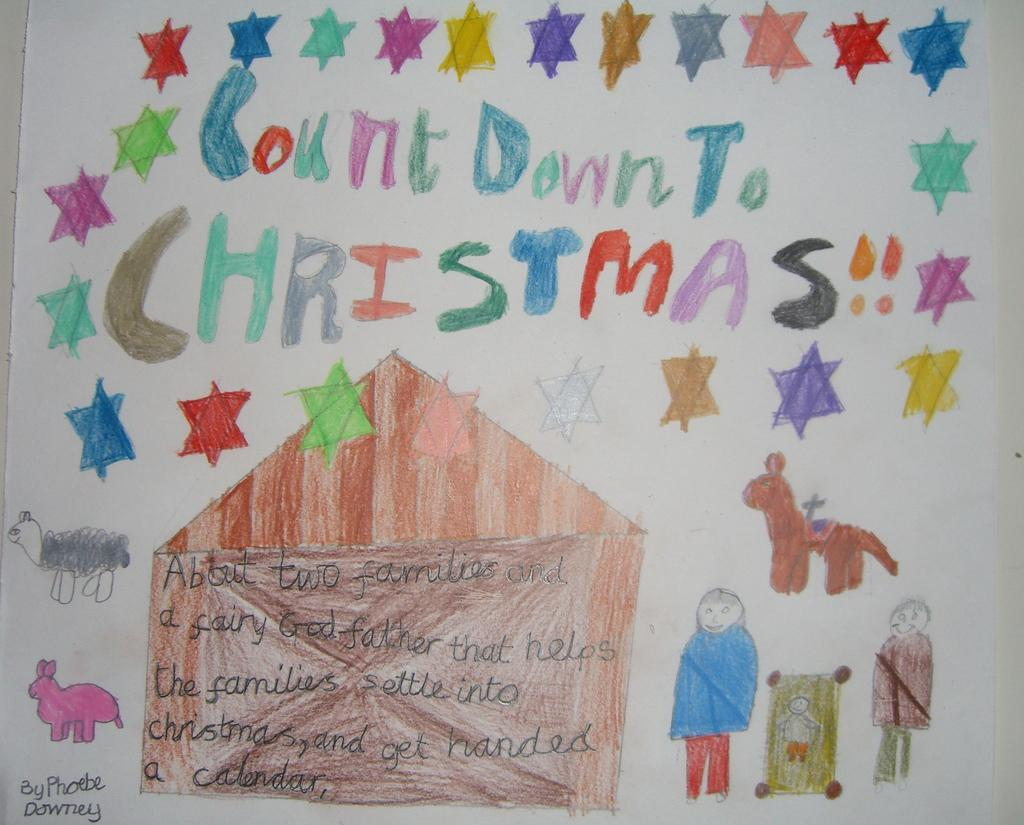What is depicted on the paper in the image? There is art on the paper in the image. What else can be seen on the paper besides the art? There is text visible in the image. What type of apparatus is being used to create the art in the image? There is no apparatus visible in the image; it only shows the art and text on the paper. How many people are attending the party in the image? There is no party depicted in the image; it only shows the art and text on the paper. 